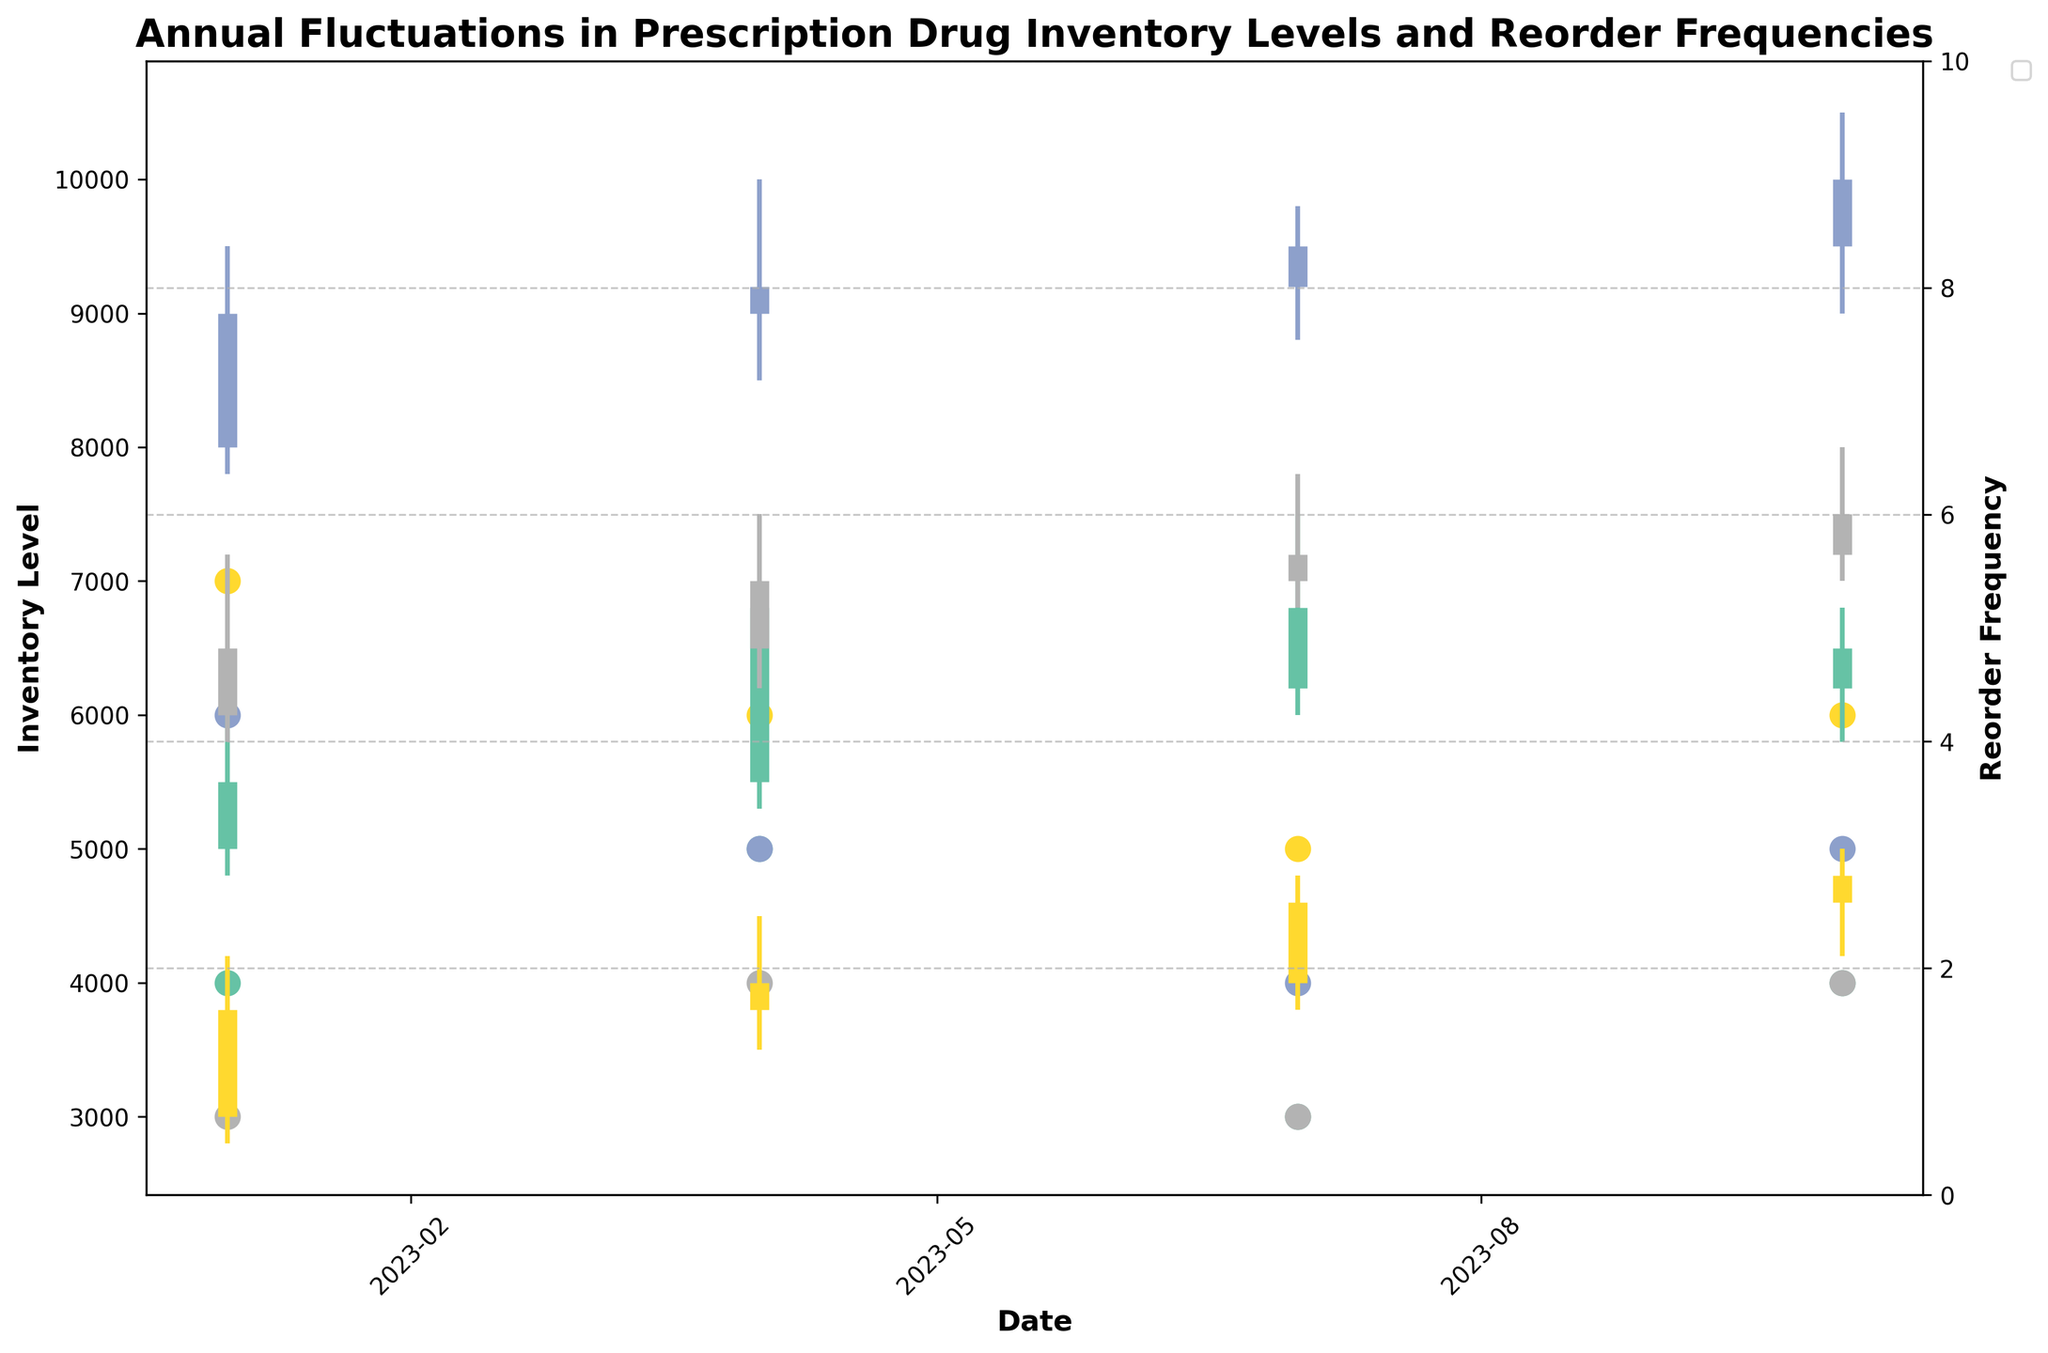What is the title of the figure? The title of the figure is displayed at the top and provides an overview of the chart's focus.
Answer: Annual Fluctuations in Prescription Drug Inventory Levels and Reorder Frequencies Which drug has the highest inventory level in January? Look at the vertical lines in January and identify the highest point for each drug. Metformin has the highest point.
Answer: Metformin How many times does Lipitor's inventory reorder occur in a year? Add the reorder frequencies for Lipitor shown by the scatter points over each quarter. Lipitor: 4 + 5 + 3 + 4.
Answer: 16 What is the average Close inventory level of Amoxicillin for the year? Add the Close values for Amoxicillin for all quarters and divide by 4. Calculation: (3800+4000+4600+4800) / 4.
Answer: 4300 Which drug has the smallest fluctuation between Low and High in July? Calculate the difference between High and Low for all drugs in July. Amoxicillin: 4800-3800=1000, Lipitor: 7500-6000=1500, Metformin: 9800-8800=1000, Omeprazole: 7800-6800=1000. All three have small fluctuations of 1000.
Answer: Amoxicillin, Metformin, Omeprazole During which quarter does Omeprazole have the highest Close inventory level? Examine the Close values for Omeprazole across all quarters and identify the highest one. Omeprazole's highest Close value is 7500 in October.
Answer: October Compare the average reorder frequency between Lipitor and Metformin over the year. Which has a higher average and by how much? Calculate the average reorder frequency for Lipitor and Metformin and compare. Lipitor: (4+5+3+4)/4 = 4, Metformin: (6+5+4+5)/4 = 5. Metformin has a higher average.
Answer: Metformin by 1 Which drug had an increased inventory level in all consecutive quarters? Check if each drug's Close value increases quarter-over-quarter. Metformin has increased from 9000 to 9200 to 9500 to 10000.
Answer: Metformin How does the inventory level of Omeprazole in October compare to its inventory level in January? Check the Close values for Omeprazole in January (6500) and October (7500), then compare.
Answer: October's level is higher by 1000 Which drug shows the least variation between the Low and High inventory levels over the entire year? Sum the differences between Low and High for each quarter and compare. Amoxicillin: (4200-2800)+(4500-3500)+(4800-3800)+(5000-4200)=3200 Lipitor: (6200-4800)+(7000-5300)+(7500-6000)+(6800-5800)=3600 Metformin: (9500-7800)+(10000-8500)+(9800-8800)+(10500-9000)=4200 Omeprazole: (7200-5800)+(7500-6200)+(7800-6800)+(8000-7000)=3200
Answer: Amoxicillin and Omeprazole 